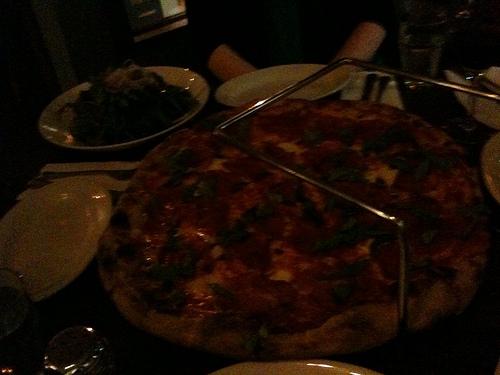How many plates are there?
Keep it brief. 5. Is this a restaurant?
Short answer required. Yes. Why is it dark in this photo?
Write a very short answer. No light. What is the food in the middle of the table?
Keep it brief. Pizza. 